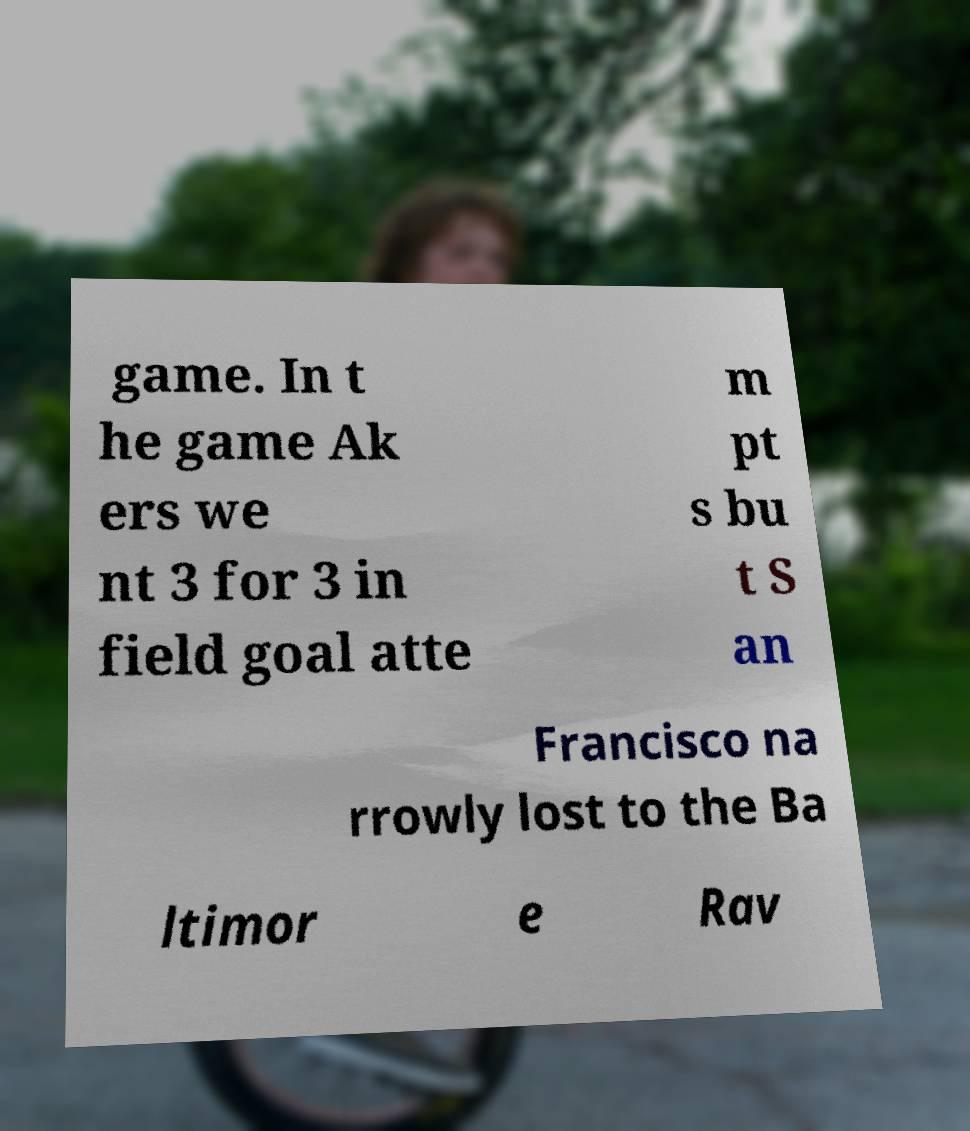Could you extract and type out the text from this image? game. In t he game Ak ers we nt 3 for 3 in field goal atte m pt s bu t S an Francisco na rrowly lost to the Ba ltimor e Rav 